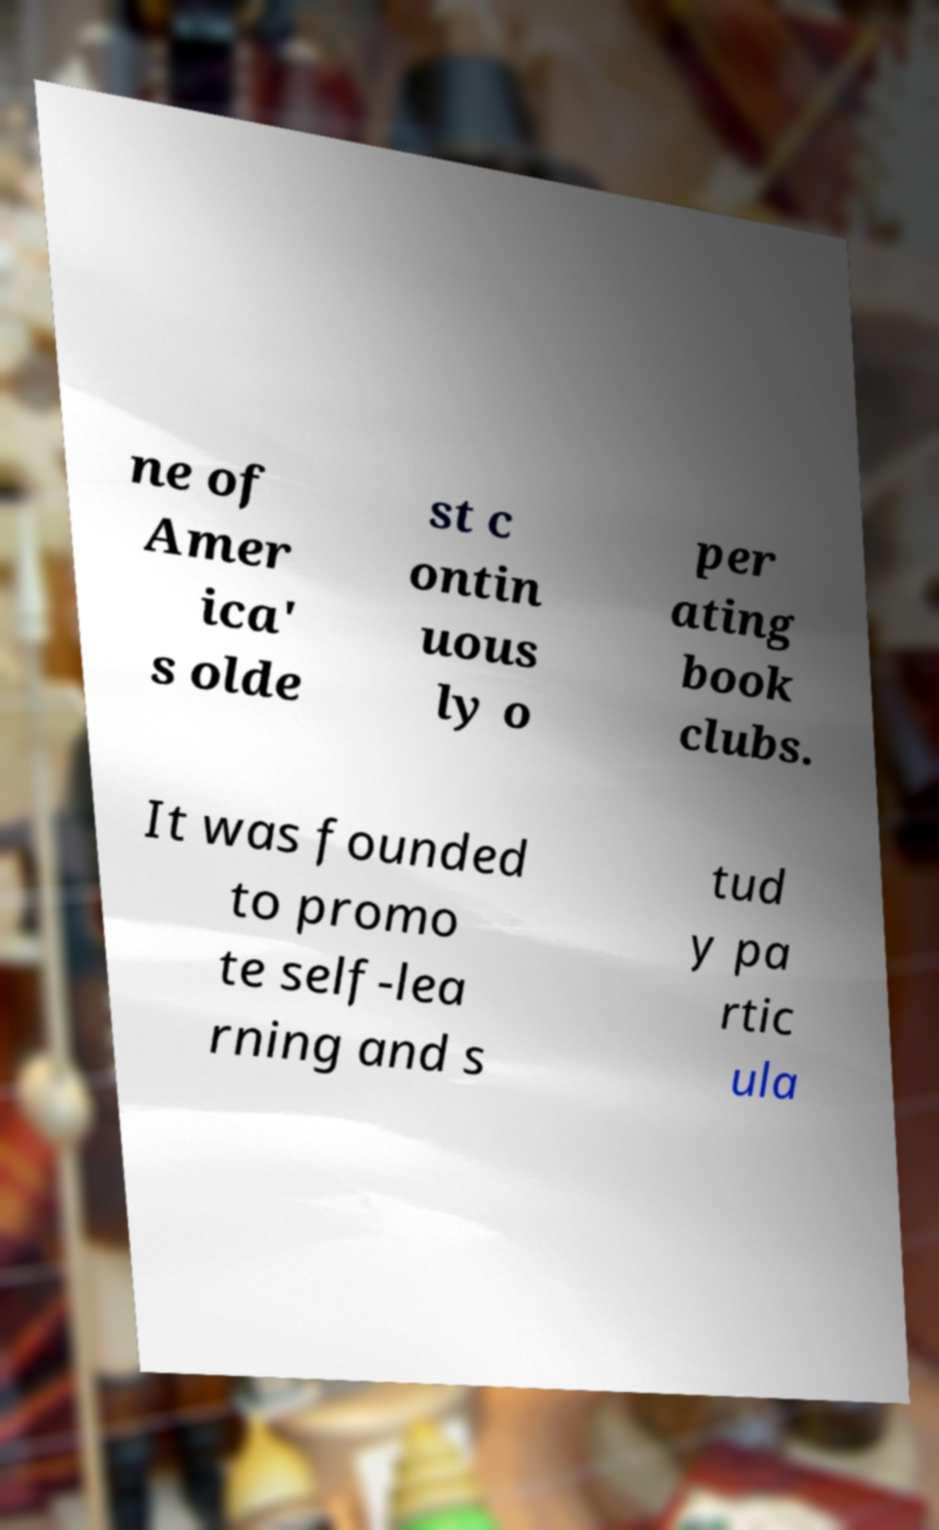Can you read and provide the text displayed in the image?This photo seems to have some interesting text. Can you extract and type it out for me? ne of Amer ica' s olde st c ontin uous ly o per ating book clubs. It was founded to promo te self-lea rning and s tud y pa rtic ula 